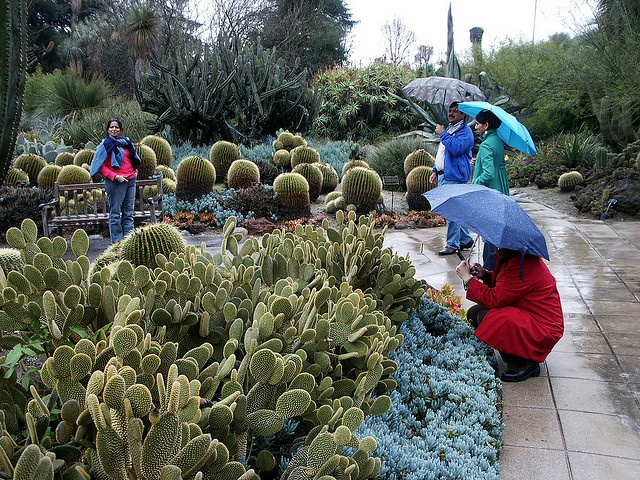Describe the objects in this image and their specific colors. I can see people in black, maroon, brown, and darkgray tones, umbrella in black, gray, blue, and lightblue tones, bench in black, gray, darkgray, and darkgreen tones, people in black, navy, blue, and gray tones, and people in black, blue, darkblue, and navy tones in this image. 